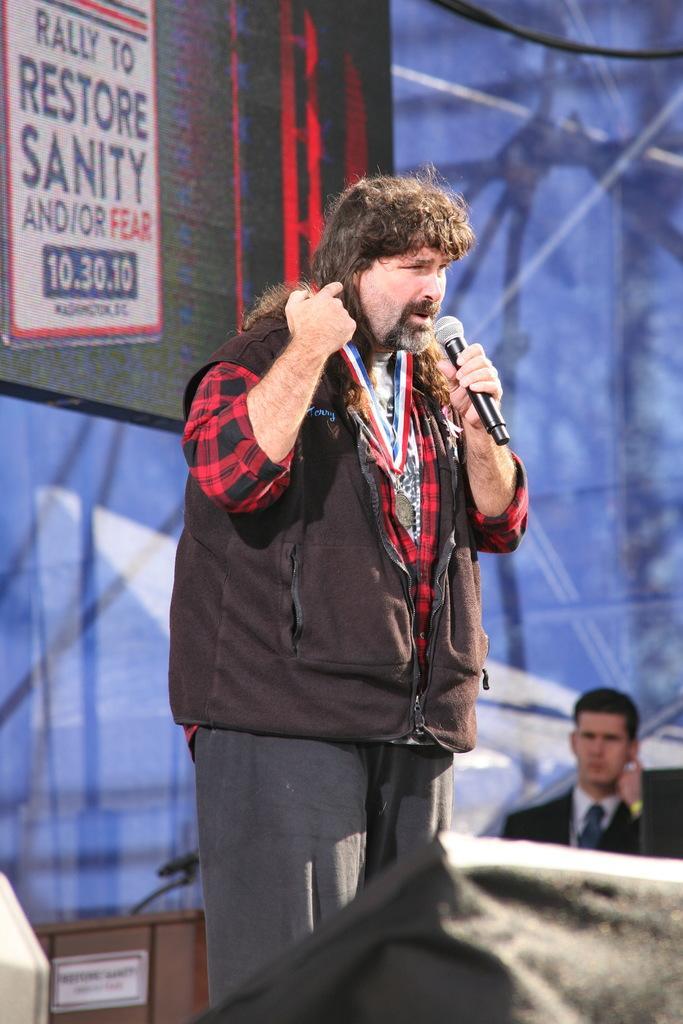Can you describe this image briefly? In this image there is a person wearing black color jacket standing and holding microphone in his hand and at the background of the image there is a black color sheet. 